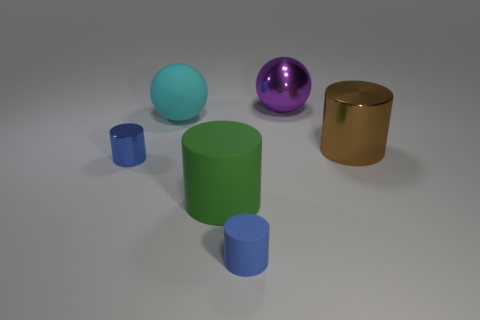Subtract 1 cylinders. How many cylinders are left? 3 Add 1 purple shiny objects. How many objects exist? 7 Subtract all balls. How many objects are left? 4 Add 4 big brown cylinders. How many big brown cylinders exist? 5 Subtract 0 cyan cubes. How many objects are left? 6 Subtract all big rubber objects. Subtract all large rubber objects. How many objects are left? 2 Add 3 matte cylinders. How many matte cylinders are left? 5 